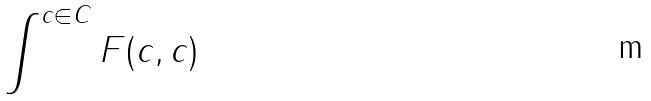Convert formula to latex. <formula><loc_0><loc_0><loc_500><loc_500>\int ^ { c \in C } F ( c , c )</formula> 